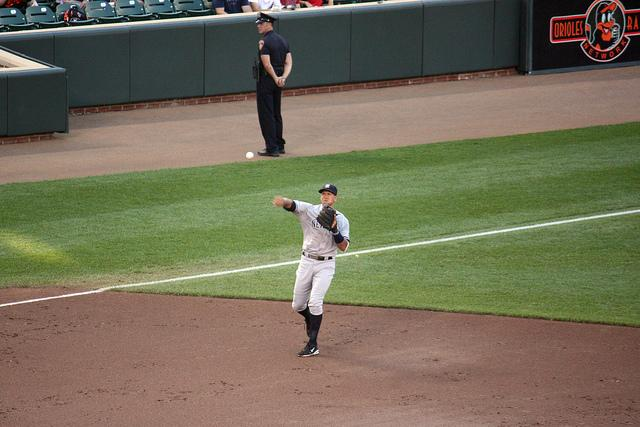What profession is the man facing the crowd?

Choices:
A) cook
B) police officer
C) janitor
D) librarian police officer 